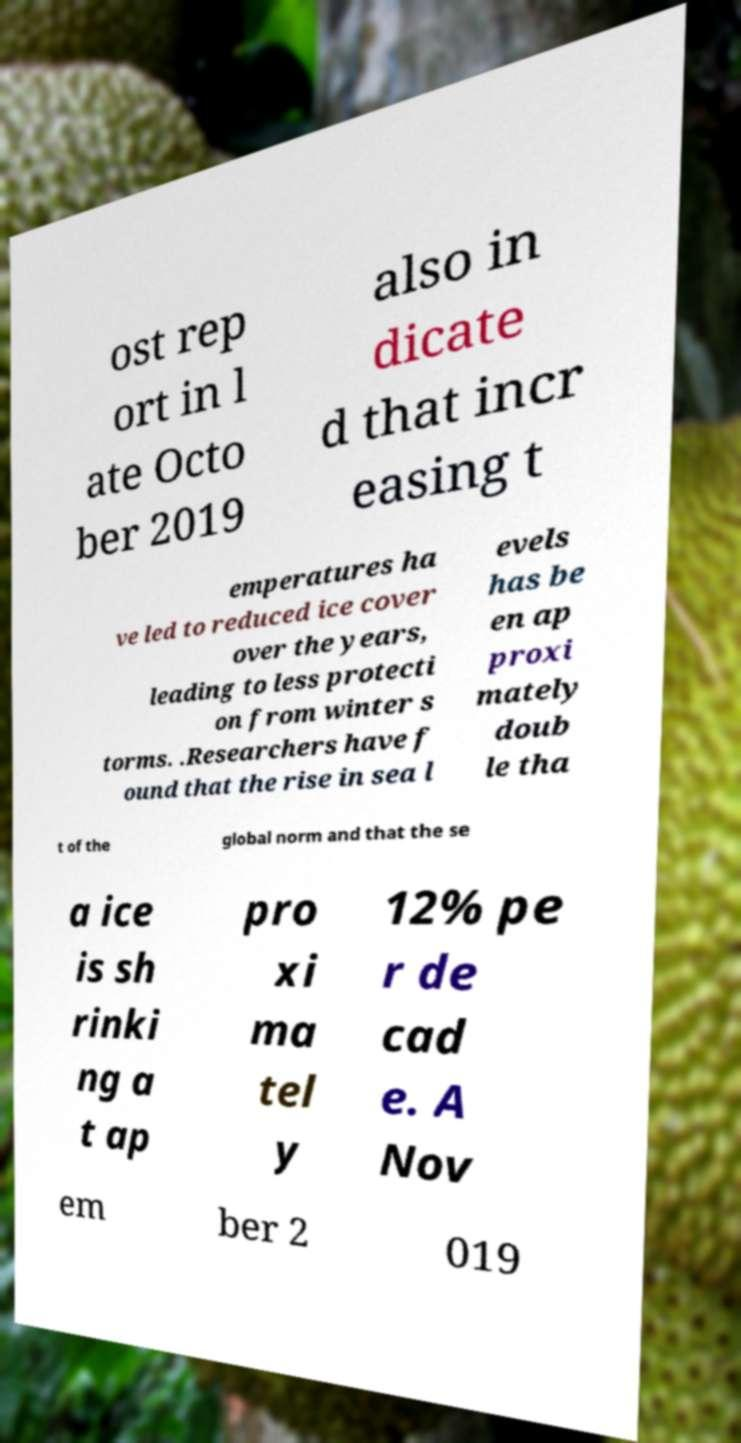Please identify and transcribe the text found in this image. ost rep ort in l ate Octo ber 2019 also in dicate d that incr easing t emperatures ha ve led to reduced ice cover over the years, leading to less protecti on from winter s torms. .Researchers have f ound that the rise in sea l evels has be en ap proxi mately doub le tha t of the global norm and that the se a ice is sh rinki ng a t ap pro xi ma tel y 12% pe r de cad e. A Nov em ber 2 019 